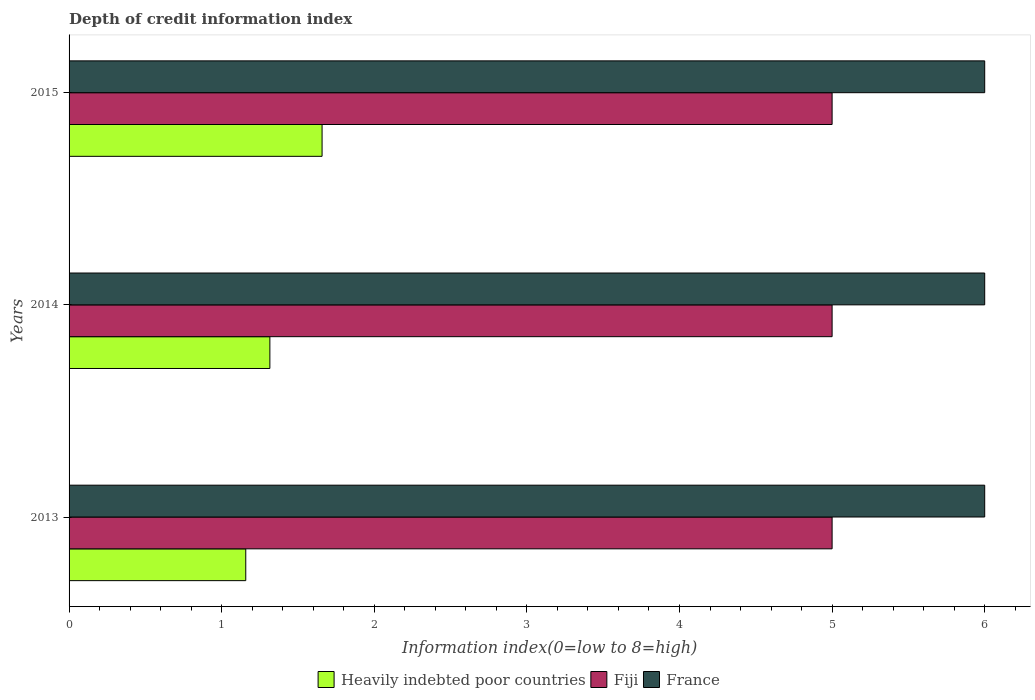What is the information index in France in 2015?
Give a very brief answer. 6. Across all years, what is the maximum information index in France?
Provide a succinct answer. 6. Across all years, what is the minimum information index in Fiji?
Your response must be concise. 5. In which year was the information index in Heavily indebted poor countries maximum?
Your response must be concise. 2015. What is the total information index in Heavily indebted poor countries in the graph?
Offer a terse response. 4.13. What is the difference between the information index in Heavily indebted poor countries in 2013 and that in 2015?
Your answer should be very brief. -0.5. What is the difference between the information index in France in 2013 and the information index in Fiji in 2015?
Keep it short and to the point. 1. What is the average information index in Heavily indebted poor countries per year?
Provide a succinct answer. 1.38. In the year 2015, what is the difference between the information index in Heavily indebted poor countries and information index in Fiji?
Your response must be concise. -3.34. Is the information index in France in 2013 less than that in 2015?
Your response must be concise. No. Is the difference between the information index in Heavily indebted poor countries in 2013 and 2014 greater than the difference between the information index in Fiji in 2013 and 2014?
Ensure brevity in your answer.  No. What is the difference between the highest and the second highest information index in France?
Provide a short and direct response. 0. In how many years, is the information index in France greater than the average information index in France taken over all years?
Provide a short and direct response. 0. What does the 2nd bar from the top in 2014 represents?
Provide a short and direct response. Fiji. What does the 2nd bar from the bottom in 2014 represents?
Make the answer very short. Fiji. Are all the bars in the graph horizontal?
Provide a succinct answer. Yes. How many years are there in the graph?
Your response must be concise. 3. What is the difference between two consecutive major ticks on the X-axis?
Keep it short and to the point. 1. Are the values on the major ticks of X-axis written in scientific E-notation?
Your response must be concise. No. Does the graph contain any zero values?
Ensure brevity in your answer.  No. Does the graph contain grids?
Give a very brief answer. No. How many legend labels are there?
Ensure brevity in your answer.  3. How are the legend labels stacked?
Give a very brief answer. Horizontal. What is the title of the graph?
Offer a terse response. Depth of credit information index. What is the label or title of the X-axis?
Ensure brevity in your answer.  Information index(0=low to 8=high). What is the Information index(0=low to 8=high) in Heavily indebted poor countries in 2013?
Keep it short and to the point. 1.16. What is the Information index(0=low to 8=high) of Heavily indebted poor countries in 2014?
Offer a terse response. 1.32. What is the Information index(0=low to 8=high) of Fiji in 2014?
Ensure brevity in your answer.  5. What is the Information index(0=low to 8=high) of Heavily indebted poor countries in 2015?
Provide a short and direct response. 1.66. Across all years, what is the maximum Information index(0=low to 8=high) of Heavily indebted poor countries?
Your answer should be very brief. 1.66. Across all years, what is the maximum Information index(0=low to 8=high) in Fiji?
Your response must be concise. 5. Across all years, what is the maximum Information index(0=low to 8=high) of France?
Offer a very short reply. 6. Across all years, what is the minimum Information index(0=low to 8=high) in Heavily indebted poor countries?
Make the answer very short. 1.16. Across all years, what is the minimum Information index(0=low to 8=high) in France?
Provide a short and direct response. 6. What is the total Information index(0=low to 8=high) of Heavily indebted poor countries in the graph?
Your answer should be very brief. 4.13. What is the total Information index(0=low to 8=high) of France in the graph?
Your answer should be very brief. 18. What is the difference between the Information index(0=low to 8=high) in Heavily indebted poor countries in 2013 and that in 2014?
Your answer should be very brief. -0.16. What is the difference between the Information index(0=low to 8=high) of Fiji in 2013 and that in 2014?
Provide a succinct answer. 0. What is the difference between the Information index(0=low to 8=high) in France in 2013 and that in 2014?
Provide a succinct answer. 0. What is the difference between the Information index(0=low to 8=high) of Heavily indebted poor countries in 2013 and that in 2015?
Keep it short and to the point. -0.5. What is the difference between the Information index(0=low to 8=high) in Fiji in 2013 and that in 2015?
Offer a very short reply. 0. What is the difference between the Information index(0=low to 8=high) in France in 2013 and that in 2015?
Offer a very short reply. 0. What is the difference between the Information index(0=low to 8=high) of Heavily indebted poor countries in 2014 and that in 2015?
Provide a short and direct response. -0.34. What is the difference between the Information index(0=low to 8=high) of Fiji in 2014 and that in 2015?
Ensure brevity in your answer.  0. What is the difference between the Information index(0=low to 8=high) in France in 2014 and that in 2015?
Keep it short and to the point. 0. What is the difference between the Information index(0=low to 8=high) of Heavily indebted poor countries in 2013 and the Information index(0=low to 8=high) of Fiji in 2014?
Your response must be concise. -3.84. What is the difference between the Information index(0=low to 8=high) of Heavily indebted poor countries in 2013 and the Information index(0=low to 8=high) of France in 2014?
Offer a terse response. -4.84. What is the difference between the Information index(0=low to 8=high) of Fiji in 2013 and the Information index(0=low to 8=high) of France in 2014?
Offer a terse response. -1. What is the difference between the Information index(0=low to 8=high) in Heavily indebted poor countries in 2013 and the Information index(0=low to 8=high) in Fiji in 2015?
Make the answer very short. -3.84. What is the difference between the Information index(0=low to 8=high) in Heavily indebted poor countries in 2013 and the Information index(0=low to 8=high) in France in 2015?
Offer a very short reply. -4.84. What is the difference between the Information index(0=low to 8=high) in Heavily indebted poor countries in 2014 and the Information index(0=low to 8=high) in Fiji in 2015?
Your answer should be compact. -3.68. What is the difference between the Information index(0=low to 8=high) of Heavily indebted poor countries in 2014 and the Information index(0=low to 8=high) of France in 2015?
Offer a very short reply. -4.68. What is the average Information index(0=low to 8=high) in Heavily indebted poor countries per year?
Your answer should be compact. 1.38. What is the average Information index(0=low to 8=high) of Fiji per year?
Make the answer very short. 5. In the year 2013, what is the difference between the Information index(0=low to 8=high) in Heavily indebted poor countries and Information index(0=low to 8=high) in Fiji?
Offer a terse response. -3.84. In the year 2013, what is the difference between the Information index(0=low to 8=high) of Heavily indebted poor countries and Information index(0=low to 8=high) of France?
Provide a succinct answer. -4.84. In the year 2013, what is the difference between the Information index(0=low to 8=high) of Fiji and Information index(0=low to 8=high) of France?
Provide a short and direct response. -1. In the year 2014, what is the difference between the Information index(0=low to 8=high) in Heavily indebted poor countries and Information index(0=low to 8=high) in Fiji?
Offer a terse response. -3.68. In the year 2014, what is the difference between the Information index(0=low to 8=high) in Heavily indebted poor countries and Information index(0=low to 8=high) in France?
Provide a short and direct response. -4.68. In the year 2015, what is the difference between the Information index(0=low to 8=high) of Heavily indebted poor countries and Information index(0=low to 8=high) of Fiji?
Your response must be concise. -3.34. In the year 2015, what is the difference between the Information index(0=low to 8=high) in Heavily indebted poor countries and Information index(0=low to 8=high) in France?
Offer a very short reply. -4.34. In the year 2015, what is the difference between the Information index(0=low to 8=high) in Fiji and Information index(0=low to 8=high) in France?
Provide a short and direct response. -1. What is the ratio of the Information index(0=low to 8=high) of Heavily indebted poor countries in 2013 to that in 2015?
Your answer should be compact. 0.7. What is the ratio of the Information index(0=low to 8=high) in Heavily indebted poor countries in 2014 to that in 2015?
Offer a terse response. 0.79. What is the ratio of the Information index(0=low to 8=high) of France in 2014 to that in 2015?
Your answer should be very brief. 1. What is the difference between the highest and the second highest Information index(0=low to 8=high) in Heavily indebted poor countries?
Ensure brevity in your answer.  0.34. What is the difference between the highest and the lowest Information index(0=low to 8=high) of Heavily indebted poor countries?
Offer a very short reply. 0.5. What is the difference between the highest and the lowest Information index(0=low to 8=high) of Fiji?
Ensure brevity in your answer.  0. 